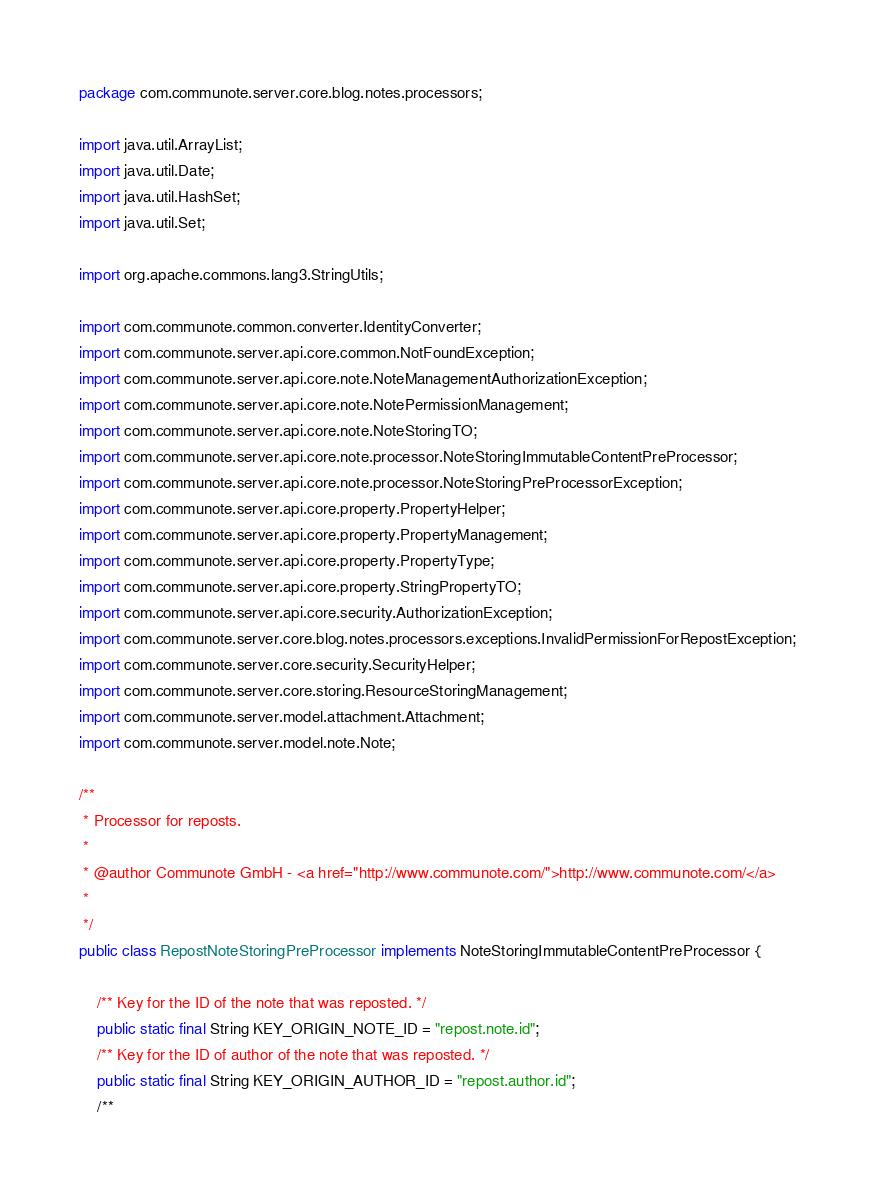Convert code to text. <code><loc_0><loc_0><loc_500><loc_500><_Java_>package com.communote.server.core.blog.notes.processors;

import java.util.ArrayList;
import java.util.Date;
import java.util.HashSet;
import java.util.Set;

import org.apache.commons.lang3.StringUtils;

import com.communote.common.converter.IdentityConverter;
import com.communote.server.api.core.common.NotFoundException;
import com.communote.server.api.core.note.NoteManagementAuthorizationException;
import com.communote.server.api.core.note.NotePermissionManagement;
import com.communote.server.api.core.note.NoteStoringTO;
import com.communote.server.api.core.note.processor.NoteStoringImmutableContentPreProcessor;
import com.communote.server.api.core.note.processor.NoteStoringPreProcessorException;
import com.communote.server.api.core.property.PropertyHelper;
import com.communote.server.api.core.property.PropertyManagement;
import com.communote.server.api.core.property.PropertyType;
import com.communote.server.api.core.property.StringPropertyTO;
import com.communote.server.api.core.security.AuthorizationException;
import com.communote.server.core.blog.notes.processors.exceptions.InvalidPermissionForRepostException;
import com.communote.server.core.security.SecurityHelper;
import com.communote.server.core.storing.ResourceStoringManagement;
import com.communote.server.model.attachment.Attachment;
import com.communote.server.model.note.Note;

/**
 * Processor for reposts.
 *
 * @author Communote GmbH - <a href="http://www.communote.com/">http://www.communote.com/</a>
 *
 */
public class RepostNoteStoringPreProcessor implements NoteStoringImmutableContentPreProcessor {

    /** Key for the ID of the note that was reposted. */
    public static final String KEY_ORIGIN_NOTE_ID = "repost.note.id";
    /** Key for the ID of author of the note that was reposted. */
    public static final String KEY_ORIGIN_AUTHOR_ID = "repost.author.id";
    /**</code> 